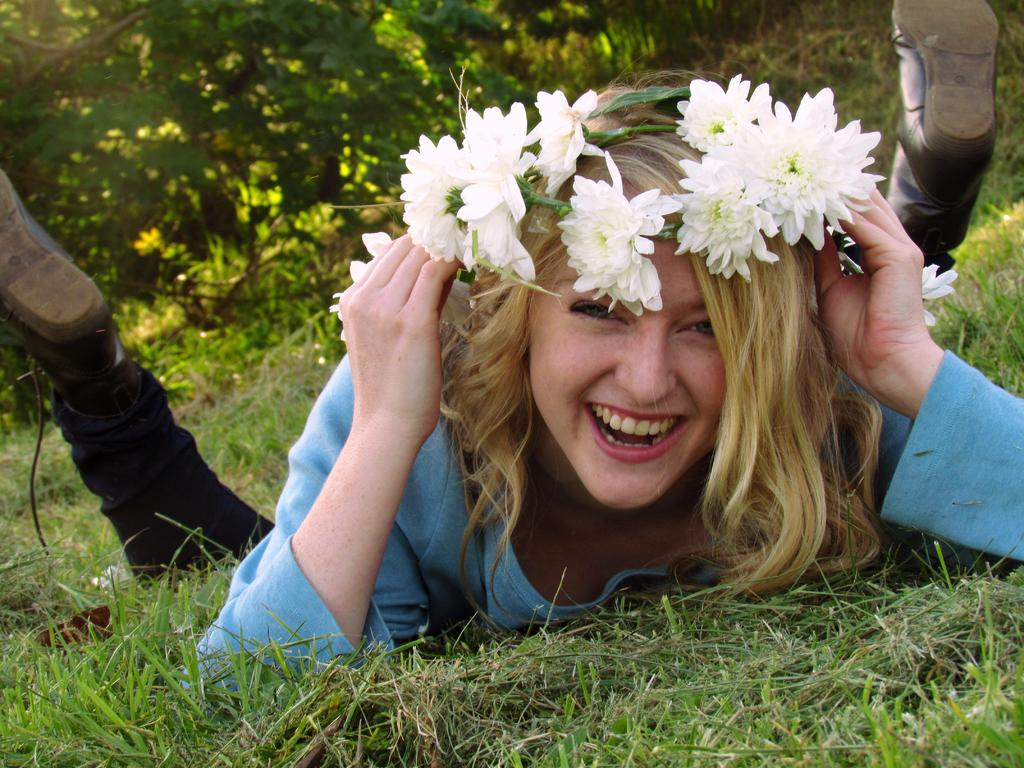What type of vegetation can be seen in the image? There is grass, trees, and flowers in the image. Can you describe the natural environment in the image? The natural environment includes grass, trees, and flowers. Is there a person present in the image? Yes, there is a woman in the image. What type of history can be seen in the image? There is no history present in the image; it features a natural environment with grass, trees, flowers, and a woman. How is the glue used in the image? There is no glue present in the image. 